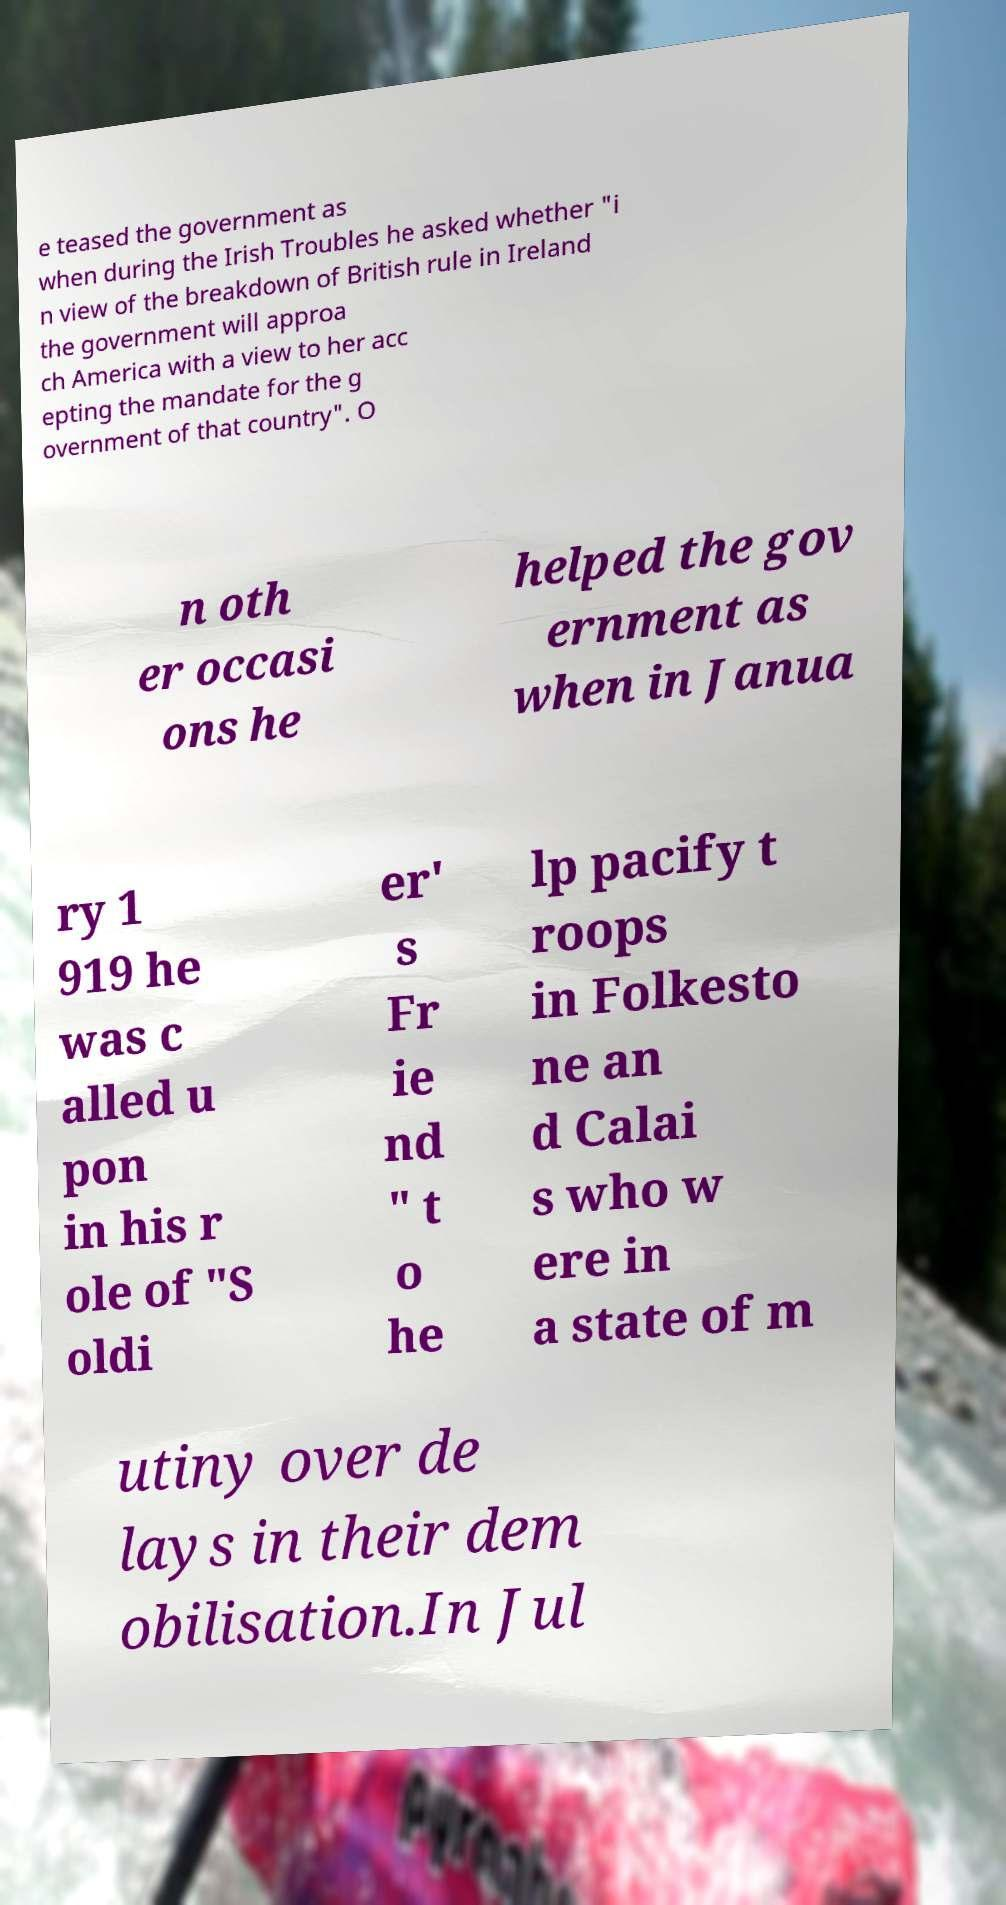For documentation purposes, I need the text within this image transcribed. Could you provide that? e teased the government as when during the Irish Troubles he asked whether "i n view of the breakdown of British rule in Ireland the government will approa ch America with a view to her acc epting the mandate for the g overnment of that country". O n oth er occasi ons he helped the gov ernment as when in Janua ry 1 919 he was c alled u pon in his r ole of "S oldi er' s Fr ie nd " t o he lp pacify t roops in Folkesto ne an d Calai s who w ere in a state of m utiny over de lays in their dem obilisation.In Jul 